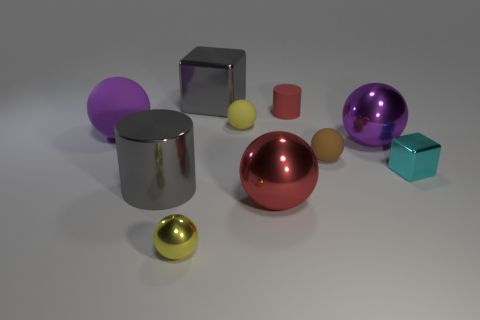Are there the same number of small balls behind the large purple matte object and red metal balls that are on the right side of the tiny cyan cube?
Your response must be concise. No. Are there any other things that are made of the same material as the red sphere?
Ensure brevity in your answer.  Yes. Does the red ball have the same size as the gray object that is behind the cyan block?
Provide a succinct answer. Yes. What material is the yellow sphere that is to the left of the block to the left of the tiny red matte object?
Ensure brevity in your answer.  Metal. Are there an equal number of brown balls that are to the left of the big cube and big brown shiny objects?
Your answer should be compact. Yes. There is a matte sphere that is both on the left side of the small brown rubber sphere and on the right side of the big rubber ball; what is its size?
Offer a very short reply. Small. There is a big shiny thing that is behind the small yellow object behind the purple matte sphere; what color is it?
Give a very brief answer. Gray. What number of red things are large blocks or tiny cylinders?
Your answer should be very brief. 1. What color is the tiny sphere that is behind the big gray cylinder and in front of the big purple shiny sphere?
Provide a succinct answer. Brown. What number of small objects are purple shiny balls or blue balls?
Your response must be concise. 0. 